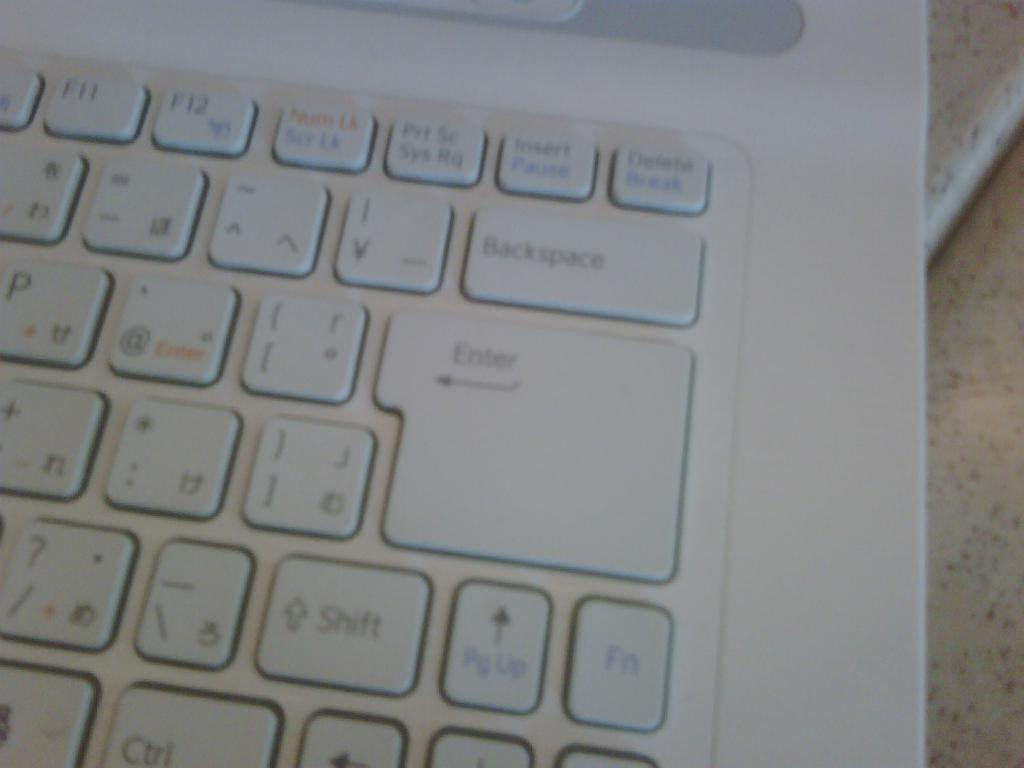<image>
Relay a brief, clear account of the picture shown. White keyboard with a giant Enter key under the Backspace key. 